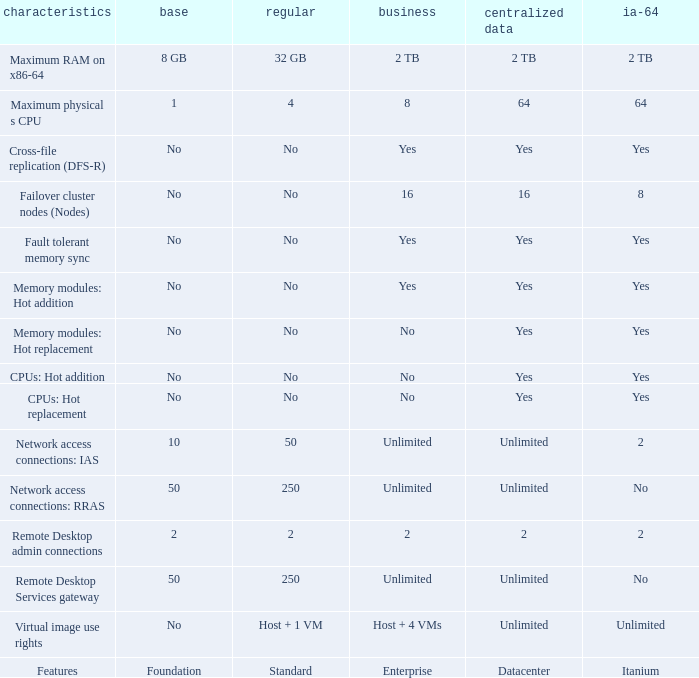What Datacenter is listed against the network access connections: rras Feature? Unlimited. 